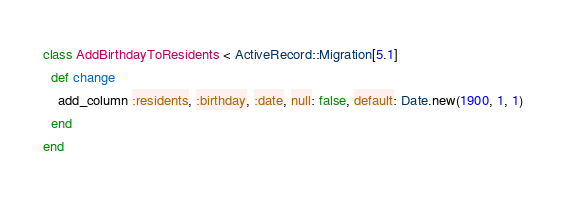<code> <loc_0><loc_0><loc_500><loc_500><_Ruby_>class AddBirthdayToResidents < ActiveRecord::Migration[5.1]
  def change
    add_column :residents, :birthday, :date, null: false, default: Date.new(1900, 1, 1)
  end
end
</code> 